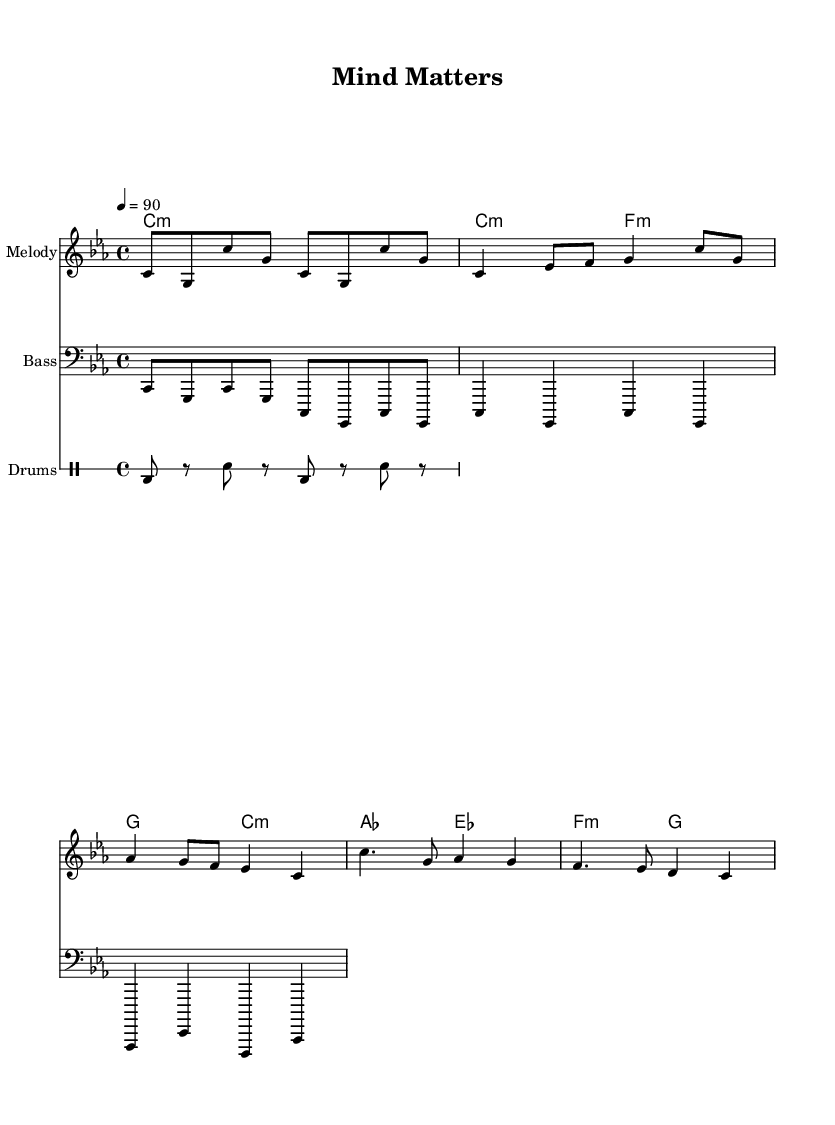What is the key signature of this music? The key signature displayed at the beginning of the sheet music indicates the key of C minor, which typically has three flats.
Answer: C minor What is the time signature of this piece? The time signature is found at the beginning of the score, which is 4/4, meaning there are four beats in every measure.
Answer: 4/4 What is the tempo marking for this composition? The tempo marking indicates the speed of the piece, which is set at 90 beats per minute, found in the tempo section of the music.
Answer: 90 How many measures are in the verse section? By counting the distinct musical phrases in the verse, we find that there are four measures present. Each line contributes to the total count.
Answer: 4 What is the primary theme of the lyrics in the verse? The verse addresses the need for support and understanding within school environments, emphasizing students' emotional concerns.
Answer: Support and understanding What rhythmic pattern is used in the drum section? Analyzing the drum pattern reveals that it consists of alternating bass and snare hits, creating a consistent rhythmic drive throughout.
Answer: Alternating bass and snare How does the chorus change from the verse in terms of content? In the chorus, the focus shifts from individual concerns to a collective message about breaking stigma and changing rules, marking a thematic transition in the song.
Answer: Collective message 